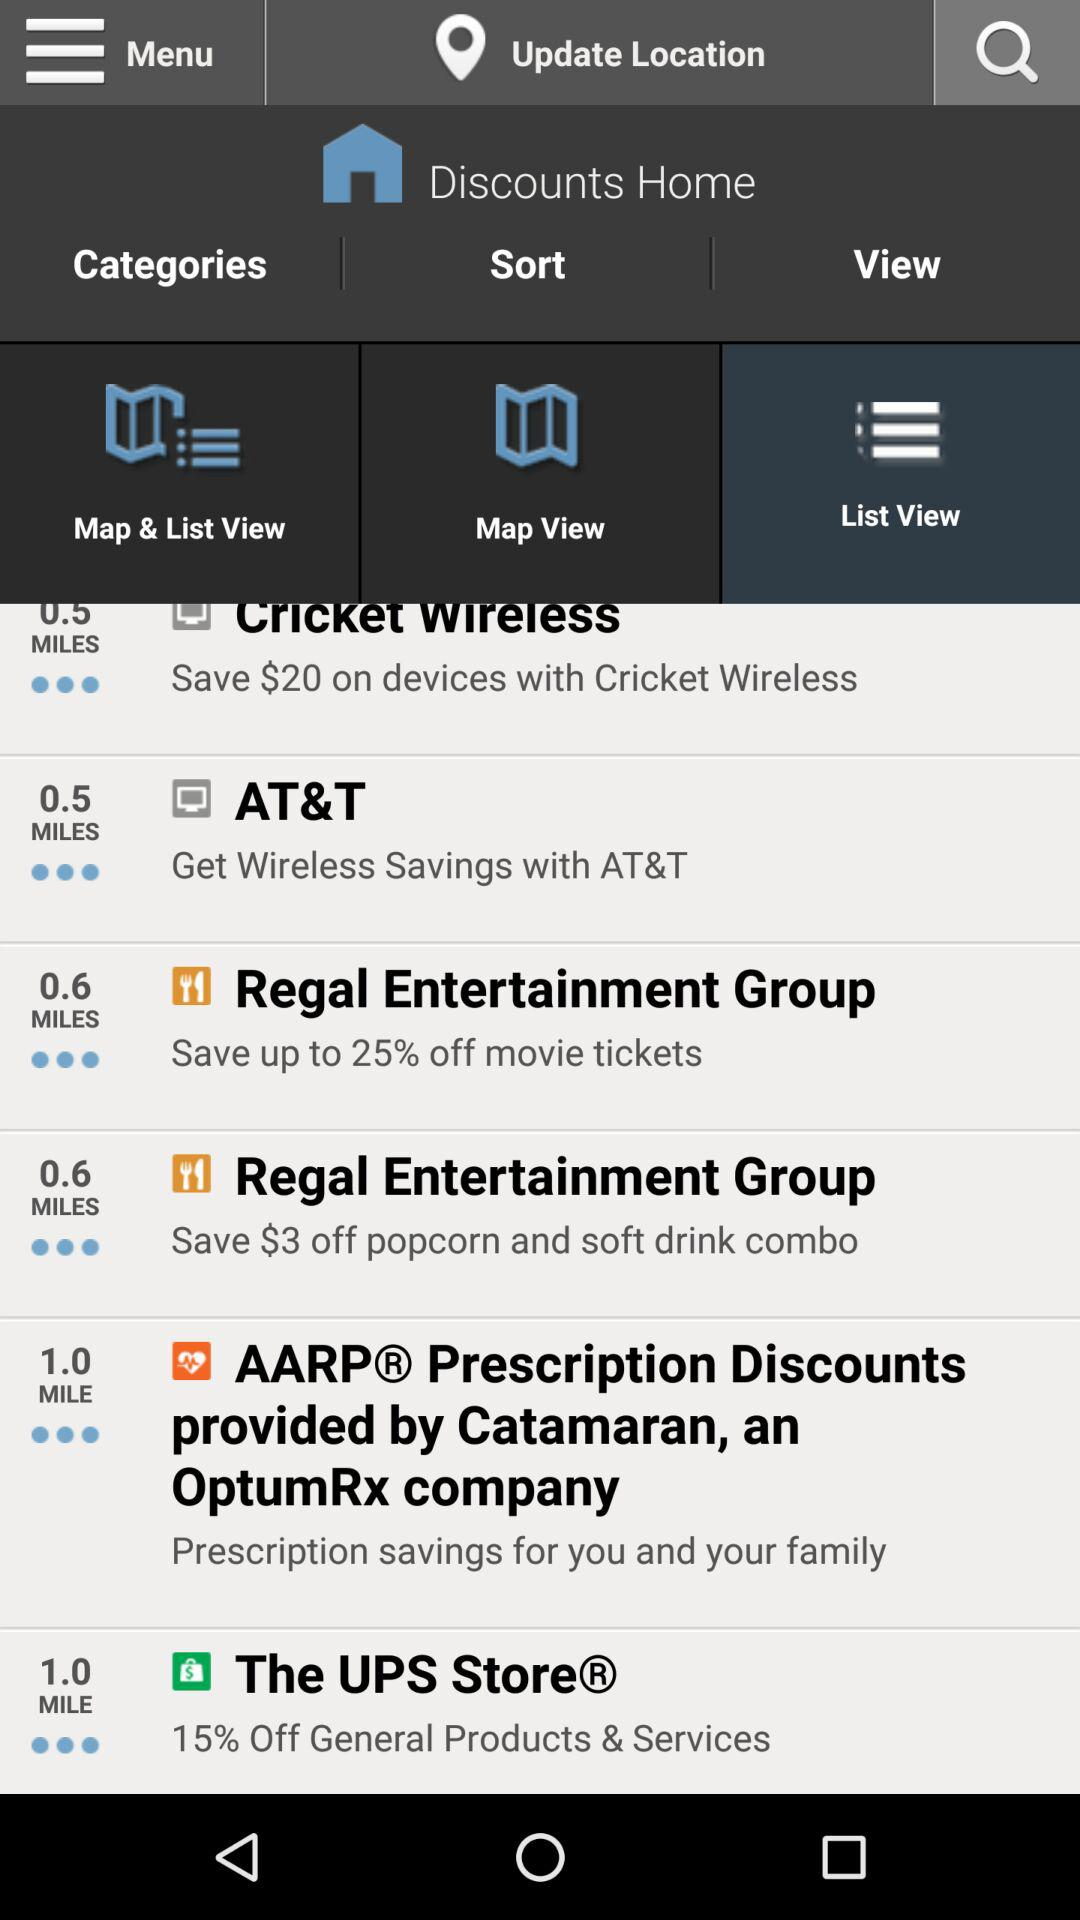Which tab is selected? The selected tab is "List View". 